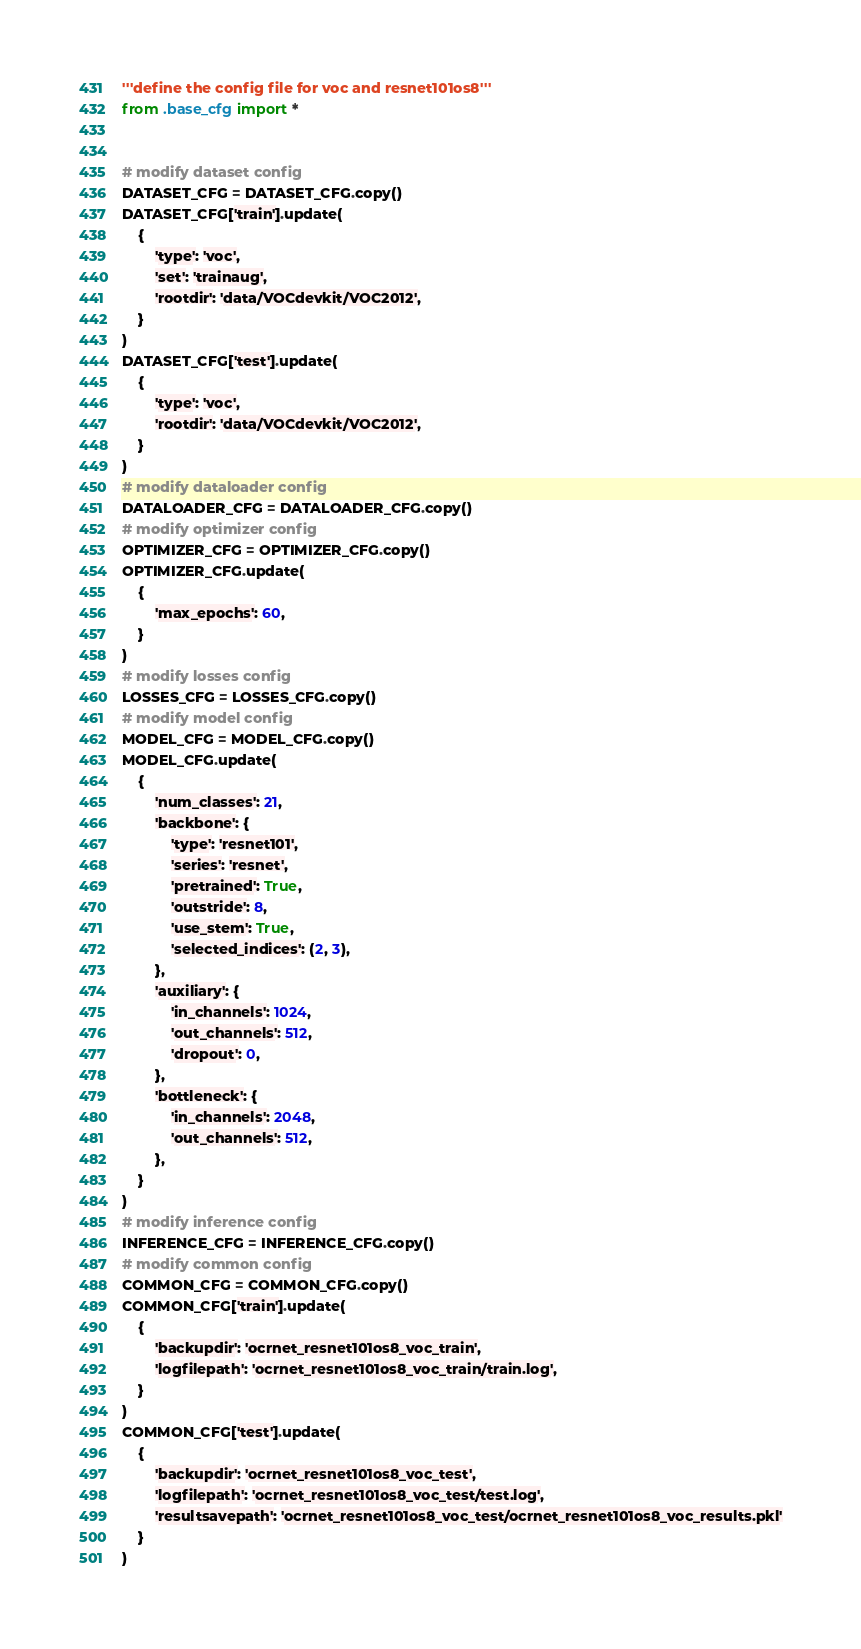Convert code to text. <code><loc_0><loc_0><loc_500><loc_500><_Python_>'''define the config file for voc and resnet101os8'''
from .base_cfg import *


# modify dataset config
DATASET_CFG = DATASET_CFG.copy()
DATASET_CFG['train'].update(
    {
        'type': 'voc',
        'set': 'trainaug',
        'rootdir': 'data/VOCdevkit/VOC2012',
    }
)
DATASET_CFG['test'].update(
    {
        'type': 'voc',
        'rootdir': 'data/VOCdevkit/VOC2012',
    }
)
# modify dataloader config
DATALOADER_CFG = DATALOADER_CFG.copy()
# modify optimizer config
OPTIMIZER_CFG = OPTIMIZER_CFG.copy()
OPTIMIZER_CFG.update(
    {
        'max_epochs': 60,
    }
)
# modify losses config
LOSSES_CFG = LOSSES_CFG.copy()
# modify model config
MODEL_CFG = MODEL_CFG.copy()
MODEL_CFG.update(
    {
        'num_classes': 21,
        'backbone': {
            'type': 'resnet101',
            'series': 'resnet',
            'pretrained': True,
            'outstride': 8,
            'use_stem': True,
            'selected_indices': (2, 3),
        },
        'auxiliary': {
            'in_channels': 1024,
            'out_channels': 512,
            'dropout': 0,
        },
        'bottleneck': {
            'in_channels': 2048,
            'out_channels': 512,
        },
    }
)
# modify inference config
INFERENCE_CFG = INFERENCE_CFG.copy()
# modify common config
COMMON_CFG = COMMON_CFG.copy()
COMMON_CFG['train'].update(
    {
        'backupdir': 'ocrnet_resnet101os8_voc_train',
        'logfilepath': 'ocrnet_resnet101os8_voc_train/train.log',
    }
)
COMMON_CFG['test'].update(
    {
        'backupdir': 'ocrnet_resnet101os8_voc_test',
        'logfilepath': 'ocrnet_resnet101os8_voc_test/test.log',
        'resultsavepath': 'ocrnet_resnet101os8_voc_test/ocrnet_resnet101os8_voc_results.pkl'
    }
)</code> 